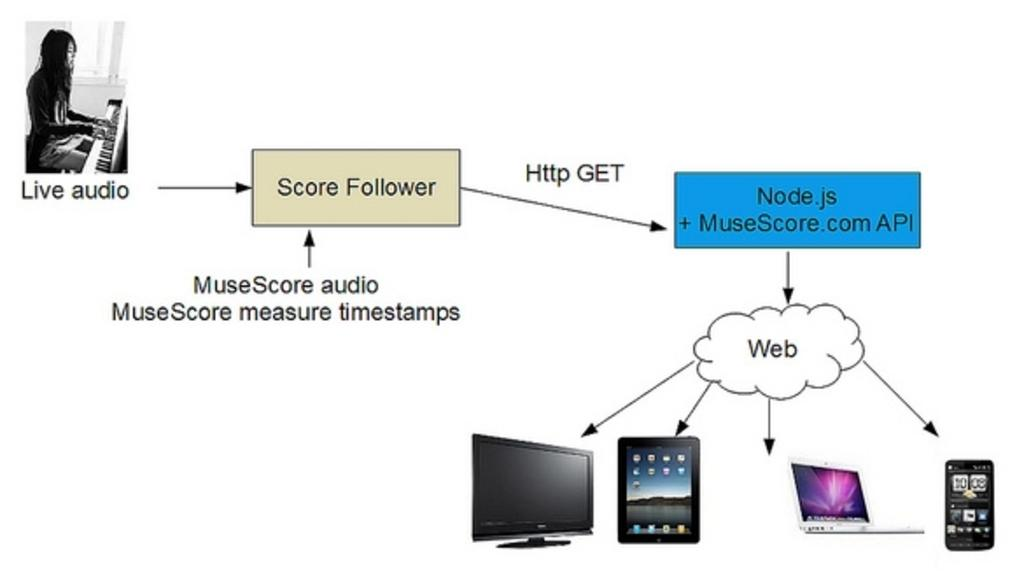<image>
Relay a brief, clear account of the picture shown. On the top left there is a picture of a girl playing music with the words live audio below the photo. 